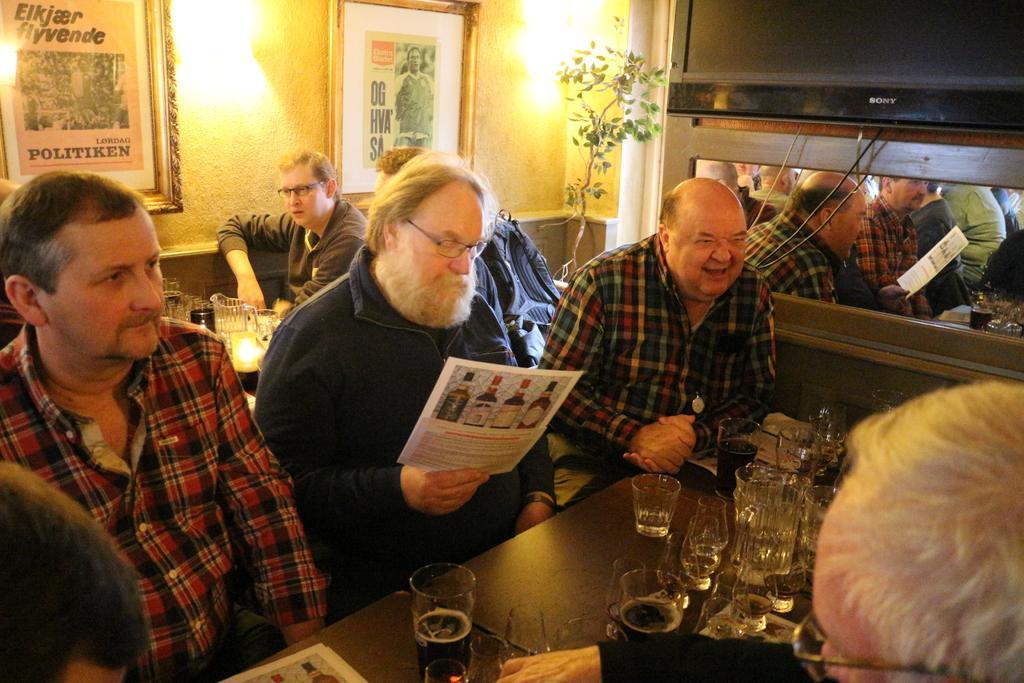In one or two sentences, can you explain what this image depicts? There are group of persons sitting in front of a table which has some glasses and drinks on it. 